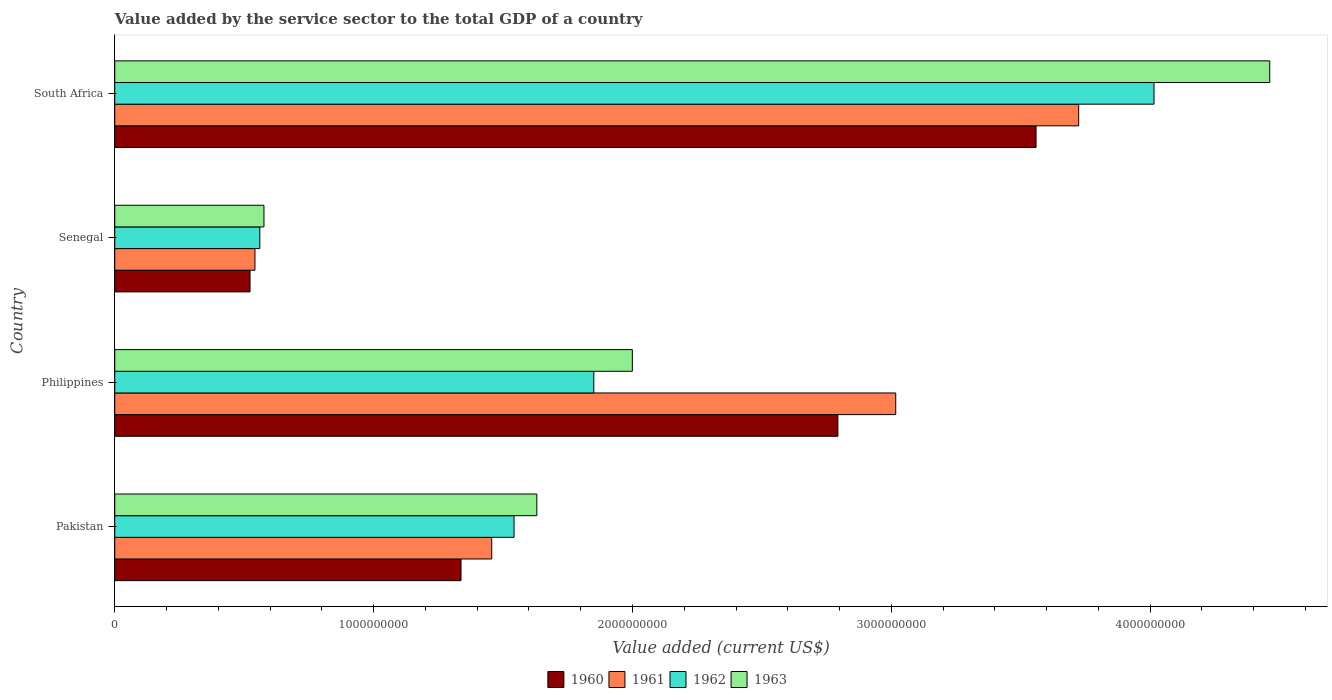Are the number of bars per tick equal to the number of legend labels?
Your answer should be compact. Yes. How many bars are there on the 3rd tick from the top?
Keep it short and to the point. 4. How many bars are there on the 2nd tick from the bottom?
Provide a succinct answer. 4. What is the label of the 1st group of bars from the top?
Provide a short and direct response. South Africa. In how many cases, is the number of bars for a given country not equal to the number of legend labels?
Give a very brief answer. 0. What is the value added by the service sector to the total GDP in 1962 in Senegal?
Provide a short and direct response. 5.60e+08. Across all countries, what is the maximum value added by the service sector to the total GDP in 1960?
Your answer should be very brief. 3.56e+09. Across all countries, what is the minimum value added by the service sector to the total GDP in 1961?
Ensure brevity in your answer.  5.42e+08. In which country was the value added by the service sector to the total GDP in 1960 maximum?
Your answer should be compact. South Africa. In which country was the value added by the service sector to the total GDP in 1962 minimum?
Your answer should be very brief. Senegal. What is the total value added by the service sector to the total GDP in 1960 in the graph?
Give a very brief answer. 8.21e+09. What is the difference between the value added by the service sector to the total GDP in 1960 in Pakistan and that in Senegal?
Keep it short and to the point. 8.15e+08. What is the difference between the value added by the service sector to the total GDP in 1963 in Senegal and the value added by the service sector to the total GDP in 1961 in Pakistan?
Your answer should be compact. -8.80e+08. What is the average value added by the service sector to the total GDP in 1961 per country?
Keep it short and to the point. 2.18e+09. What is the difference between the value added by the service sector to the total GDP in 1962 and value added by the service sector to the total GDP in 1961 in Senegal?
Keep it short and to the point. 1.87e+07. What is the ratio of the value added by the service sector to the total GDP in 1962 in Pakistan to that in Senegal?
Your answer should be compact. 2.75. Is the value added by the service sector to the total GDP in 1960 in Pakistan less than that in Senegal?
Give a very brief answer. No. Is the difference between the value added by the service sector to the total GDP in 1962 in Pakistan and South Africa greater than the difference between the value added by the service sector to the total GDP in 1961 in Pakistan and South Africa?
Offer a very short reply. No. What is the difference between the highest and the second highest value added by the service sector to the total GDP in 1960?
Ensure brevity in your answer.  7.66e+08. What is the difference between the highest and the lowest value added by the service sector to the total GDP in 1960?
Provide a succinct answer. 3.04e+09. Is the sum of the value added by the service sector to the total GDP in 1963 in Senegal and South Africa greater than the maximum value added by the service sector to the total GDP in 1961 across all countries?
Offer a very short reply. Yes. What does the 4th bar from the top in Senegal represents?
Ensure brevity in your answer.  1960. Is it the case that in every country, the sum of the value added by the service sector to the total GDP in 1963 and value added by the service sector to the total GDP in 1962 is greater than the value added by the service sector to the total GDP in 1961?
Your answer should be very brief. Yes. How many bars are there?
Ensure brevity in your answer.  16. Are all the bars in the graph horizontal?
Keep it short and to the point. Yes. Does the graph contain any zero values?
Your response must be concise. No. Does the graph contain grids?
Your answer should be compact. No. Where does the legend appear in the graph?
Make the answer very short. Bottom center. How many legend labels are there?
Ensure brevity in your answer.  4. What is the title of the graph?
Provide a short and direct response. Value added by the service sector to the total GDP of a country. Does "1982" appear as one of the legend labels in the graph?
Provide a succinct answer. No. What is the label or title of the X-axis?
Offer a terse response. Value added (current US$). What is the Value added (current US$) of 1960 in Pakistan?
Your answer should be very brief. 1.34e+09. What is the Value added (current US$) of 1961 in Pakistan?
Give a very brief answer. 1.46e+09. What is the Value added (current US$) of 1962 in Pakistan?
Provide a succinct answer. 1.54e+09. What is the Value added (current US$) of 1963 in Pakistan?
Give a very brief answer. 1.63e+09. What is the Value added (current US$) in 1960 in Philippines?
Your answer should be compact. 2.79e+09. What is the Value added (current US$) in 1961 in Philippines?
Keep it short and to the point. 3.02e+09. What is the Value added (current US$) of 1962 in Philippines?
Make the answer very short. 1.85e+09. What is the Value added (current US$) of 1963 in Philippines?
Your response must be concise. 2.00e+09. What is the Value added (current US$) in 1960 in Senegal?
Offer a very short reply. 5.23e+08. What is the Value added (current US$) of 1961 in Senegal?
Make the answer very short. 5.42e+08. What is the Value added (current US$) in 1962 in Senegal?
Your answer should be very brief. 5.60e+08. What is the Value added (current US$) of 1963 in Senegal?
Ensure brevity in your answer.  5.76e+08. What is the Value added (current US$) in 1960 in South Africa?
Your answer should be compact. 3.56e+09. What is the Value added (current US$) in 1961 in South Africa?
Keep it short and to the point. 3.72e+09. What is the Value added (current US$) in 1962 in South Africa?
Provide a short and direct response. 4.01e+09. What is the Value added (current US$) of 1963 in South Africa?
Make the answer very short. 4.46e+09. Across all countries, what is the maximum Value added (current US$) of 1960?
Your response must be concise. 3.56e+09. Across all countries, what is the maximum Value added (current US$) in 1961?
Your response must be concise. 3.72e+09. Across all countries, what is the maximum Value added (current US$) in 1962?
Keep it short and to the point. 4.01e+09. Across all countries, what is the maximum Value added (current US$) in 1963?
Your answer should be very brief. 4.46e+09. Across all countries, what is the minimum Value added (current US$) of 1960?
Give a very brief answer. 5.23e+08. Across all countries, what is the minimum Value added (current US$) of 1961?
Your answer should be very brief. 5.42e+08. Across all countries, what is the minimum Value added (current US$) in 1962?
Offer a terse response. 5.60e+08. Across all countries, what is the minimum Value added (current US$) in 1963?
Give a very brief answer. 5.76e+08. What is the total Value added (current US$) of 1960 in the graph?
Give a very brief answer. 8.21e+09. What is the total Value added (current US$) in 1961 in the graph?
Your answer should be very brief. 8.74e+09. What is the total Value added (current US$) in 1962 in the graph?
Offer a terse response. 7.97e+09. What is the total Value added (current US$) of 1963 in the graph?
Make the answer very short. 8.67e+09. What is the difference between the Value added (current US$) in 1960 in Pakistan and that in Philippines?
Offer a terse response. -1.46e+09. What is the difference between the Value added (current US$) of 1961 in Pakistan and that in Philippines?
Offer a very short reply. -1.56e+09. What is the difference between the Value added (current US$) in 1962 in Pakistan and that in Philippines?
Offer a very short reply. -3.08e+08. What is the difference between the Value added (current US$) in 1963 in Pakistan and that in Philippines?
Provide a short and direct response. -3.69e+08. What is the difference between the Value added (current US$) of 1960 in Pakistan and that in Senegal?
Give a very brief answer. 8.15e+08. What is the difference between the Value added (current US$) of 1961 in Pakistan and that in Senegal?
Provide a short and direct response. 9.15e+08. What is the difference between the Value added (current US$) of 1962 in Pakistan and that in Senegal?
Your response must be concise. 9.82e+08. What is the difference between the Value added (current US$) in 1963 in Pakistan and that in Senegal?
Keep it short and to the point. 1.05e+09. What is the difference between the Value added (current US$) in 1960 in Pakistan and that in South Africa?
Give a very brief answer. -2.22e+09. What is the difference between the Value added (current US$) in 1961 in Pakistan and that in South Africa?
Offer a terse response. -2.27e+09. What is the difference between the Value added (current US$) of 1962 in Pakistan and that in South Africa?
Your response must be concise. -2.47e+09. What is the difference between the Value added (current US$) of 1963 in Pakistan and that in South Africa?
Ensure brevity in your answer.  -2.83e+09. What is the difference between the Value added (current US$) of 1960 in Philippines and that in Senegal?
Give a very brief answer. 2.27e+09. What is the difference between the Value added (current US$) of 1961 in Philippines and that in Senegal?
Ensure brevity in your answer.  2.48e+09. What is the difference between the Value added (current US$) of 1962 in Philippines and that in Senegal?
Your answer should be very brief. 1.29e+09. What is the difference between the Value added (current US$) in 1963 in Philippines and that in Senegal?
Offer a very short reply. 1.42e+09. What is the difference between the Value added (current US$) of 1960 in Philippines and that in South Africa?
Give a very brief answer. -7.66e+08. What is the difference between the Value added (current US$) of 1961 in Philippines and that in South Africa?
Provide a short and direct response. -7.07e+08. What is the difference between the Value added (current US$) in 1962 in Philippines and that in South Africa?
Provide a succinct answer. -2.16e+09. What is the difference between the Value added (current US$) of 1963 in Philippines and that in South Africa?
Your answer should be compact. -2.46e+09. What is the difference between the Value added (current US$) in 1960 in Senegal and that in South Africa?
Ensure brevity in your answer.  -3.04e+09. What is the difference between the Value added (current US$) in 1961 in Senegal and that in South Africa?
Offer a very short reply. -3.18e+09. What is the difference between the Value added (current US$) of 1962 in Senegal and that in South Africa?
Your answer should be compact. -3.45e+09. What is the difference between the Value added (current US$) of 1963 in Senegal and that in South Africa?
Offer a very short reply. -3.89e+09. What is the difference between the Value added (current US$) in 1960 in Pakistan and the Value added (current US$) in 1961 in Philippines?
Give a very brief answer. -1.68e+09. What is the difference between the Value added (current US$) in 1960 in Pakistan and the Value added (current US$) in 1962 in Philippines?
Your answer should be compact. -5.13e+08. What is the difference between the Value added (current US$) of 1960 in Pakistan and the Value added (current US$) of 1963 in Philippines?
Ensure brevity in your answer.  -6.62e+08. What is the difference between the Value added (current US$) in 1961 in Pakistan and the Value added (current US$) in 1962 in Philippines?
Provide a succinct answer. -3.94e+08. What is the difference between the Value added (current US$) of 1961 in Pakistan and the Value added (current US$) of 1963 in Philippines?
Ensure brevity in your answer.  -5.43e+08. What is the difference between the Value added (current US$) of 1962 in Pakistan and the Value added (current US$) of 1963 in Philippines?
Make the answer very short. -4.57e+08. What is the difference between the Value added (current US$) of 1960 in Pakistan and the Value added (current US$) of 1961 in Senegal?
Your response must be concise. 7.96e+08. What is the difference between the Value added (current US$) of 1960 in Pakistan and the Value added (current US$) of 1962 in Senegal?
Provide a succinct answer. 7.77e+08. What is the difference between the Value added (current US$) in 1960 in Pakistan and the Value added (current US$) in 1963 in Senegal?
Give a very brief answer. 7.61e+08. What is the difference between the Value added (current US$) in 1961 in Pakistan and the Value added (current US$) in 1962 in Senegal?
Your answer should be compact. 8.96e+08. What is the difference between the Value added (current US$) in 1961 in Pakistan and the Value added (current US$) in 1963 in Senegal?
Offer a terse response. 8.80e+08. What is the difference between the Value added (current US$) in 1962 in Pakistan and the Value added (current US$) in 1963 in Senegal?
Provide a short and direct response. 9.66e+08. What is the difference between the Value added (current US$) in 1960 in Pakistan and the Value added (current US$) in 1961 in South Africa?
Offer a very short reply. -2.39e+09. What is the difference between the Value added (current US$) in 1960 in Pakistan and the Value added (current US$) in 1962 in South Africa?
Give a very brief answer. -2.68e+09. What is the difference between the Value added (current US$) of 1960 in Pakistan and the Value added (current US$) of 1963 in South Africa?
Offer a very short reply. -3.12e+09. What is the difference between the Value added (current US$) of 1961 in Pakistan and the Value added (current US$) of 1962 in South Africa?
Make the answer very short. -2.56e+09. What is the difference between the Value added (current US$) in 1961 in Pakistan and the Value added (current US$) in 1963 in South Africa?
Keep it short and to the point. -3.01e+09. What is the difference between the Value added (current US$) of 1962 in Pakistan and the Value added (current US$) of 1963 in South Africa?
Ensure brevity in your answer.  -2.92e+09. What is the difference between the Value added (current US$) of 1960 in Philippines and the Value added (current US$) of 1961 in Senegal?
Your answer should be very brief. 2.25e+09. What is the difference between the Value added (current US$) of 1960 in Philippines and the Value added (current US$) of 1962 in Senegal?
Give a very brief answer. 2.23e+09. What is the difference between the Value added (current US$) in 1960 in Philippines and the Value added (current US$) in 1963 in Senegal?
Provide a succinct answer. 2.22e+09. What is the difference between the Value added (current US$) in 1961 in Philippines and the Value added (current US$) in 1962 in Senegal?
Offer a terse response. 2.46e+09. What is the difference between the Value added (current US$) in 1961 in Philippines and the Value added (current US$) in 1963 in Senegal?
Your response must be concise. 2.44e+09. What is the difference between the Value added (current US$) of 1962 in Philippines and the Value added (current US$) of 1963 in Senegal?
Your answer should be compact. 1.27e+09. What is the difference between the Value added (current US$) of 1960 in Philippines and the Value added (current US$) of 1961 in South Africa?
Keep it short and to the point. -9.30e+08. What is the difference between the Value added (current US$) of 1960 in Philippines and the Value added (current US$) of 1962 in South Africa?
Make the answer very short. -1.22e+09. What is the difference between the Value added (current US$) in 1960 in Philippines and the Value added (current US$) in 1963 in South Africa?
Provide a succinct answer. -1.67e+09. What is the difference between the Value added (current US$) in 1961 in Philippines and the Value added (current US$) in 1962 in South Africa?
Offer a very short reply. -9.98e+08. What is the difference between the Value added (current US$) in 1961 in Philippines and the Value added (current US$) in 1963 in South Africa?
Keep it short and to the point. -1.44e+09. What is the difference between the Value added (current US$) of 1962 in Philippines and the Value added (current US$) of 1963 in South Africa?
Your answer should be compact. -2.61e+09. What is the difference between the Value added (current US$) in 1960 in Senegal and the Value added (current US$) in 1961 in South Africa?
Your response must be concise. -3.20e+09. What is the difference between the Value added (current US$) in 1960 in Senegal and the Value added (current US$) in 1962 in South Africa?
Make the answer very short. -3.49e+09. What is the difference between the Value added (current US$) of 1960 in Senegal and the Value added (current US$) of 1963 in South Africa?
Ensure brevity in your answer.  -3.94e+09. What is the difference between the Value added (current US$) of 1961 in Senegal and the Value added (current US$) of 1962 in South Africa?
Provide a short and direct response. -3.47e+09. What is the difference between the Value added (current US$) of 1961 in Senegal and the Value added (current US$) of 1963 in South Africa?
Make the answer very short. -3.92e+09. What is the difference between the Value added (current US$) in 1962 in Senegal and the Value added (current US$) in 1963 in South Africa?
Give a very brief answer. -3.90e+09. What is the average Value added (current US$) of 1960 per country?
Provide a short and direct response. 2.05e+09. What is the average Value added (current US$) in 1961 per country?
Your answer should be very brief. 2.18e+09. What is the average Value added (current US$) of 1962 per country?
Offer a terse response. 1.99e+09. What is the average Value added (current US$) in 1963 per country?
Offer a very short reply. 2.17e+09. What is the difference between the Value added (current US$) of 1960 and Value added (current US$) of 1961 in Pakistan?
Your response must be concise. -1.19e+08. What is the difference between the Value added (current US$) in 1960 and Value added (current US$) in 1962 in Pakistan?
Your answer should be very brief. -2.05e+08. What is the difference between the Value added (current US$) of 1960 and Value added (current US$) of 1963 in Pakistan?
Provide a short and direct response. -2.93e+08. What is the difference between the Value added (current US$) in 1961 and Value added (current US$) in 1962 in Pakistan?
Keep it short and to the point. -8.63e+07. What is the difference between the Value added (current US$) in 1961 and Value added (current US$) in 1963 in Pakistan?
Your response must be concise. -1.74e+08. What is the difference between the Value added (current US$) of 1962 and Value added (current US$) of 1963 in Pakistan?
Offer a very short reply. -8.80e+07. What is the difference between the Value added (current US$) of 1960 and Value added (current US$) of 1961 in Philippines?
Offer a terse response. -2.24e+08. What is the difference between the Value added (current US$) in 1960 and Value added (current US$) in 1962 in Philippines?
Provide a succinct answer. 9.43e+08. What is the difference between the Value added (current US$) in 1960 and Value added (current US$) in 1963 in Philippines?
Provide a short and direct response. 7.94e+08. What is the difference between the Value added (current US$) in 1961 and Value added (current US$) in 1962 in Philippines?
Make the answer very short. 1.17e+09. What is the difference between the Value added (current US$) in 1961 and Value added (current US$) in 1963 in Philippines?
Your answer should be compact. 1.02e+09. What is the difference between the Value added (current US$) of 1962 and Value added (current US$) of 1963 in Philippines?
Your response must be concise. -1.49e+08. What is the difference between the Value added (current US$) of 1960 and Value added (current US$) of 1961 in Senegal?
Make the answer very short. -1.90e+07. What is the difference between the Value added (current US$) of 1960 and Value added (current US$) of 1962 in Senegal?
Offer a very short reply. -3.77e+07. What is the difference between the Value added (current US$) of 1960 and Value added (current US$) of 1963 in Senegal?
Your response must be concise. -5.38e+07. What is the difference between the Value added (current US$) of 1961 and Value added (current US$) of 1962 in Senegal?
Offer a very short reply. -1.87e+07. What is the difference between the Value added (current US$) of 1961 and Value added (current US$) of 1963 in Senegal?
Offer a very short reply. -3.48e+07. What is the difference between the Value added (current US$) in 1962 and Value added (current US$) in 1963 in Senegal?
Your answer should be compact. -1.60e+07. What is the difference between the Value added (current US$) in 1960 and Value added (current US$) in 1961 in South Africa?
Make the answer very short. -1.65e+08. What is the difference between the Value added (current US$) of 1960 and Value added (current US$) of 1962 in South Africa?
Provide a short and direct response. -4.56e+08. What is the difference between the Value added (current US$) in 1960 and Value added (current US$) in 1963 in South Africa?
Provide a short and direct response. -9.03e+08. What is the difference between the Value added (current US$) of 1961 and Value added (current US$) of 1962 in South Africa?
Make the answer very short. -2.91e+08. What is the difference between the Value added (current US$) in 1961 and Value added (current US$) in 1963 in South Africa?
Your answer should be compact. -7.38e+08. What is the difference between the Value added (current US$) in 1962 and Value added (current US$) in 1963 in South Africa?
Offer a very short reply. -4.47e+08. What is the ratio of the Value added (current US$) in 1960 in Pakistan to that in Philippines?
Give a very brief answer. 0.48. What is the ratio of the Value added (current US$) of 1961 in Pakistan to that in Philippines?
Your answer should be very brief. 0.48. What is the ratio of the Value added (current US$) of 1962 in Pakistan to that in Philippines?
Keep it short and to the point. 0.83. What is the ratio of the Value added (current US$) of 1963 in Pakistan to that in Philippines?
Your answer should be very brief. 0.82. What is the ratio of the Value added (current US$) in 1960 in Pakistan to that in Senegal?
Offer a terse response. 2.56. What is the ratio of the Value added (current US$) in 1961 in Pakistan to that in Senegal?
Make the answer very short. 2.69. What is the ratio of the Value added (current US$) of 1962 in Pakistan to that in Senegal?
Ensure brevity in your answer.  2.75. What is the ratio of the Value added (current US$) of 1963 in Pakistan to that in Senegal?
Give a very brief answer. 2.83. What is the ratio of the Value added (current US$) of 1960 in Pakistan to that in South Africa?
Your answer should be compact. 0.38. What is the ratio of the Value added (current US$) of 1961 in Pakistan to that in South Africa?
Ensure brevity in your answer.  0.39. What is the ratio of the Value added (current US$) of 1962 in Pakistan to that in South Africa?
Your answer should be very brief. 0.38. What is the ratio of the Value added (current US$) of 1963 in Pakistan to that in South Africa?
Your answer should be compact. 0.37. What is the ratio of the Value added (current US$) of 1960 in Philippines to that in Senegal?
Make the answer very short. 5.35. What is the ratio of the Value added (current US$) of 1961 in Philippines to that in Senegal?
Give a very brief answer. 5.57. What is the ratio of the Value added (current US$) in 1962 in Philippines to that in Senegal?
Give a very brief answer. 3.3. What is the ratio of the Value added (current US$) in 1963 in Philippines to that in Senegal?
Give a very brief answer. 3.47. What is the ratio of the Value added (current US$) in 1960 in Philippines to that in South Africa?
Ensure brevity in your answer.  0.78. What is the ratio of the Value added (current US$) of 1961 in Philippines to that in South Africa?
Offer a very short reply. 0.81. What is the ratio of the Value added (current US$) of 1962 in Philippines to that in South Africa?
Offer a terse response. 0.46. What is the ratio of the Value added (current US$) in 1963 in Philippines to that in South Africa?
Make the answer very short. 0.45. What is the ratio of the Value added (current US$) in 1960 in Senegal to that in South Africa?
Your answer should be very brief. 0.15. What is the ratio of the Value added (current US$) in 1961 in Senegal to that in South Africa?
Make the answer very short. 0.15. What is the ratio of the Value added (current US$) of 1962 in Senegal to that in South Africa?
Offer a terse response. 0.14. What is the ratio of the Value added (current US$) in 1963 in Senegal to that in South Africa?
Provide a succinct answer. 0.13. What is the difference between the highest and the second highest Value added (current US$) of 1960?
Offer a terse response. 7.66e+08. What is the difference between the highest and the second highest Value added (current US$) of 1961?
Give a very brief answer. 7.07e+08. What is the difference between the highest and the second highest Value added (current US$) in 1962?
Your answer should be very brief. 2.16e+09. What is the difference between the highest and the second highest Value added (current US$) in 1963?
Provide a succinct answer. 2.46e+09. What is the difference between the highest and the lowest Value added (current US$) in 1960?
Offer a very short reply. 3.04e+09. What is the difference between the highest and the lowest Value added (current US$) in 1961?
Make the answer very short. 3.18e+09. What is the difference between the highest and the lowest Value added (current US$) of 1962?
Provide a succinct answer. 3.45e+09. What is the difference between the highest and the lowest Value added (current US$) in 1963?
Ensure brevity in your answer.  3.89e+09. 